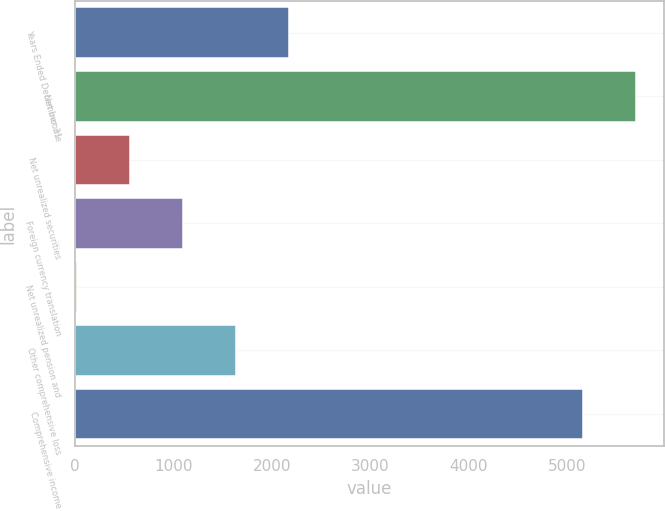<chart> <loc_0><loc_0><loc_500><loc_500><bar_chart><fcel>Years Ended December 31<fcel>Net income<fcel>Net unrealized securities<fcel>Foreign currency translation<fcel>Net unrealized pension and<fcel>Other comprehensive loss<fcel>Comprehensive income<nl><fcel>2174.6<fcel>5696.9<fcel>557.9<fcel>1096.8<fcel>19<fcel>1635.7<fcel>5158<nl></chart> 